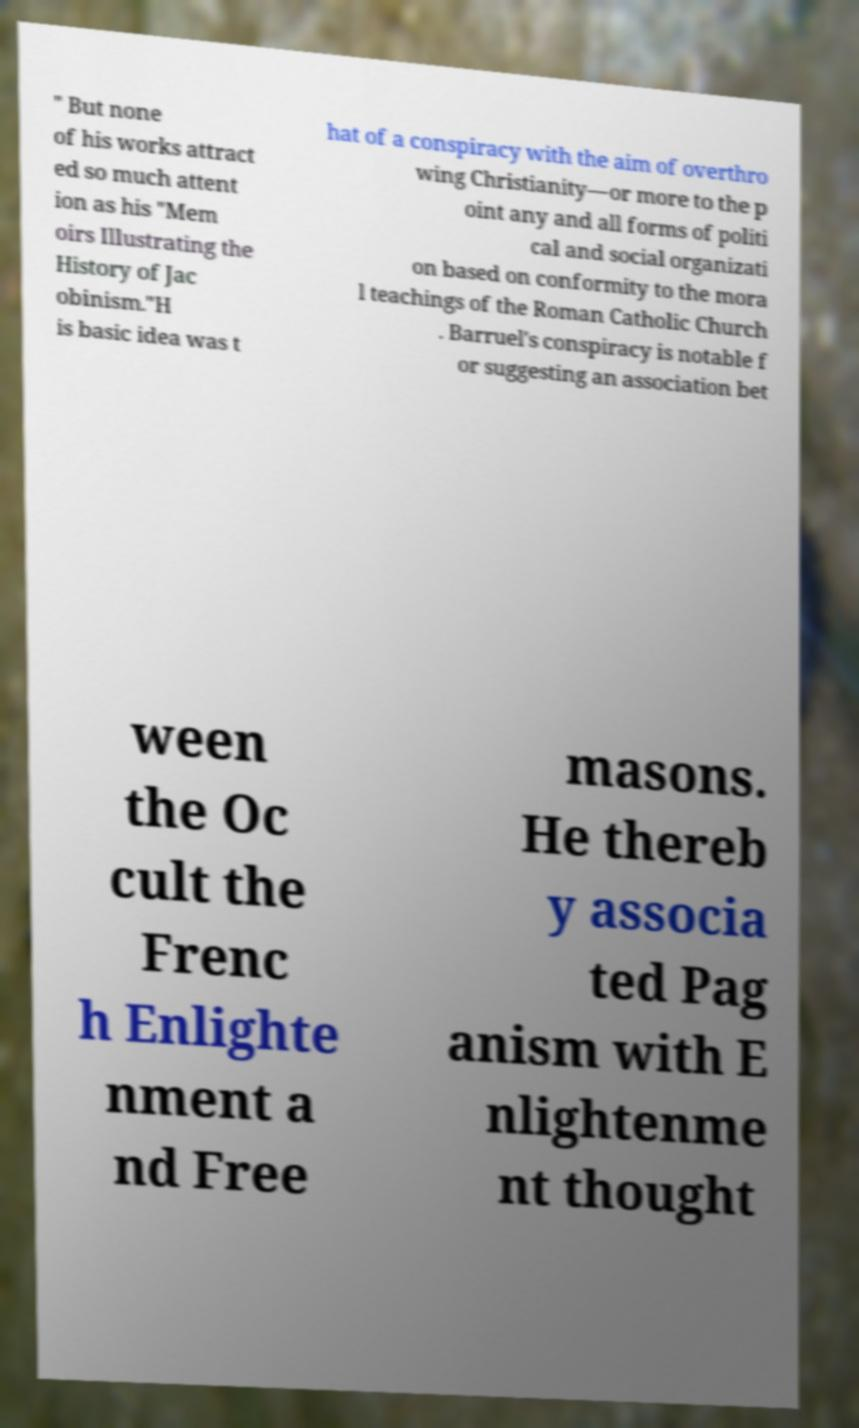Please identify and transcribe the text found in this image. " But none of his works attract ed so much attent ion as his "Mem oirs Illustrating the History of Jac obinism."H is basic idea was t hat of a conspiracy with the aim of overthro wing Christianity—or more to the p oint any and all forms of politi cal and social organizati on based on conformity to the mora l teachings of the Roman Catholic Church . Barruel's conspiracy is notable f or suggesting an association bet ween the Oc cult the Frenc h Enlighte nment a nd Free masons. He thereb y associa ted Pag anism with E nlightenme nt thought 